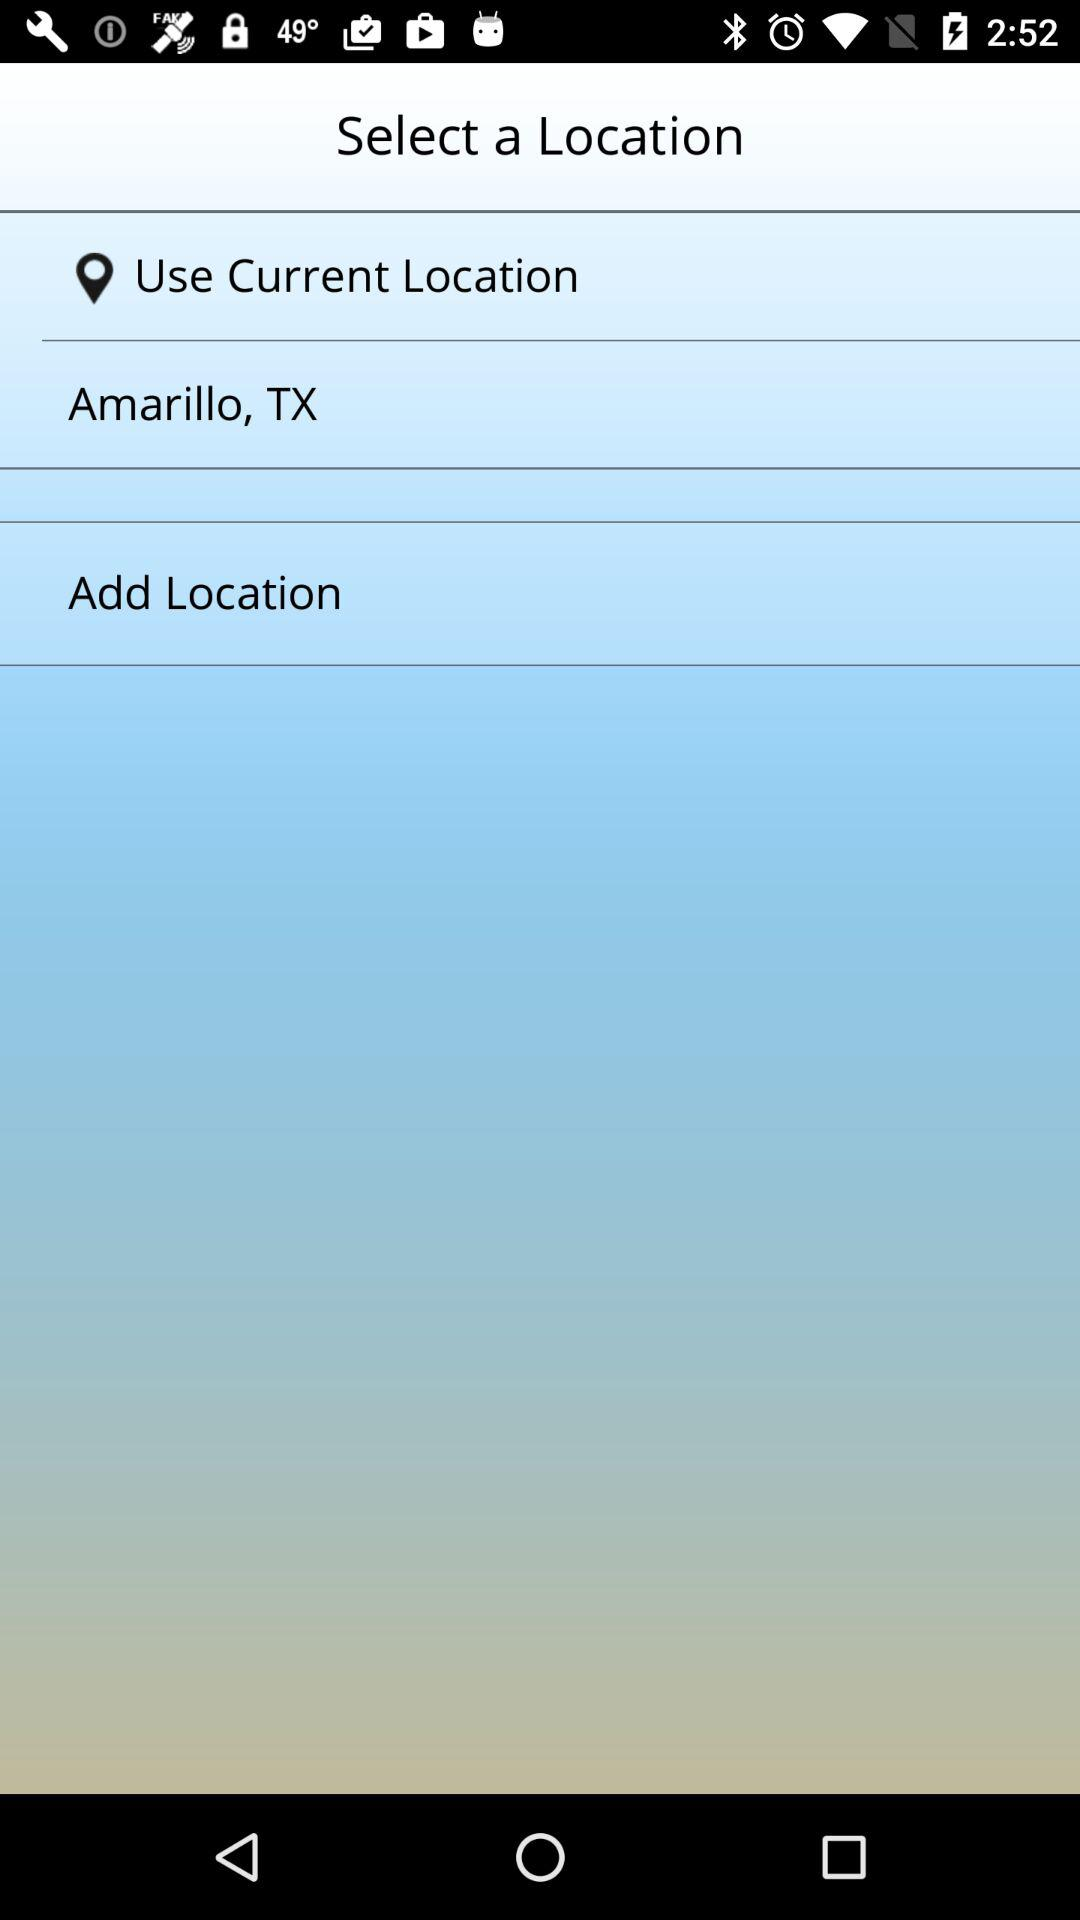What is the name of the application?
When the provided information is insufficient, respond with <no answer>. <no answer> 